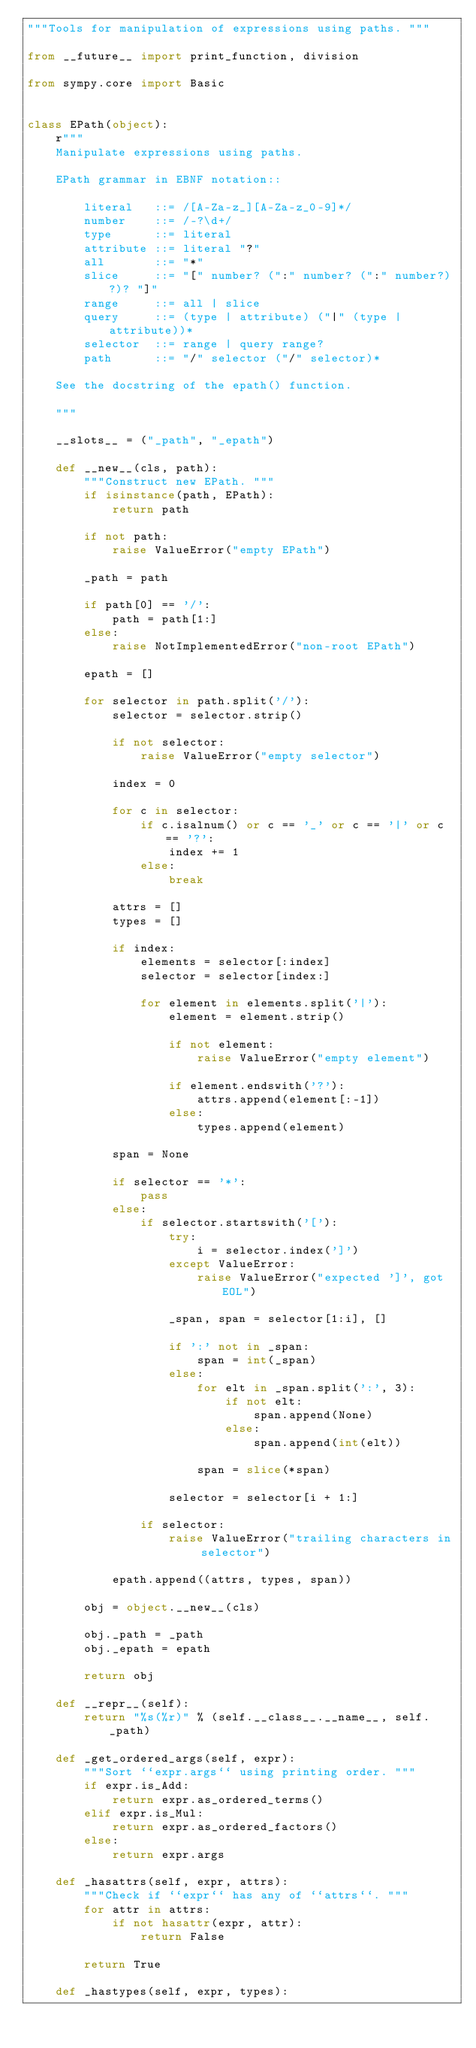<code> <loc_0><loc_0><loc_500><loc_500><_Python_>"""Tools for manipulation of expressions using paths. """

from __future__ import print_function, division

from sympy.core import Basic


class EPath(object):
    r"""
    Manipulate expressions using paths.

    EPath grammar in EBNF notation::

        literal   ::= /[A-Za-z_][A-Za-z_0-9]*/
        number    ::= /-?\d+/
        type      ::= literal
        attribute ::= literal "?"
        all       ::= "*"
        slice     ::= "[" number? (":" number? (":" number?)?)? "]"
        range     ::= all | slice
        query     ::= (type | attribute) ("|" (type | attribute))*
        selector  ::= range | query range?
        path      ::= "/" selector ("/" selector)*

    See the docstring of the epath() function.

    """

    __slots__ = ("_path", "_epath")

    def __new__(cls, path):
        """Construct new EPath. """
        if isinstance(path, EPath):
            return path

        if not path:
            raise ValueError("empty EPath")

        _path = path

        if path[0] == '/':
            path = path[1:]
        else:
            raise NotImplementedError("non-root EPath")

        epath = []

        for selector in path.split('/'):
            selector = selector.strip()

            if not selector:
                raise ValueError("empty selector")

            index = 0

            for c in selector:
                if c.isalnum() or c == '_' or c == '|' or c == '?':
                    index += 1
                else:
                    break

            attrs = []
            types = []

            if index:
                elements = selector[:index]
                selector = selector[index:]

                for element in elements.split('|'):
                    element = element.strip()

                    if not element:
                        raise ValueError("empty element")

                    if element.endswith('?'):
                        attrs.append(element[:-1])
                    else:
                        types.append(element)

            span = None

            if selector == '*':
                pass
            else:
                if selector.startswith('['):
                    try:
                        i = selector.index(']')
                    except ValueError:
                        raise ValueError("expected ']', got EOL")

                    _span, span = selector[1:i], []

                    if ':' not in _span:
                        span = int(_span)
                    else:
                        for elt in _span.split(':', 3):
                            if not elt:
                                span.append(None)
                            else:
                                span.append(int(elt))

                        span = slice(*span)

                    selector = selector[i + 1:]

                if selector:
                    raise ValueError("trailing characters in selector")

            epath.append((attrs, types, span))

        obj = object.__new__(cls)

        obj._path = _path
        obj._epath = epath

        return obj

    def __repr__(self):
        return "%s(%r)" % (self.__class__.__name__, self._path)

    def _get_ordered_args(self, expr):
        """Sort ``expr.args`` using printing order. """
        if expr.is_Add:
            return expr.as_ordered_terms()
        elif expr.is_Mul:
            return expr.as_ordered_factors()
        else:
            return expr.args

    def _hasattrs(self, expr, attrs):
        """Check if ``expr`` has any of ``attrs``. """
        for attr in attrs:
            if not hasattr(expr, attr):
                return False

        return True

    def _hastypes(self, expr, types):</code> 